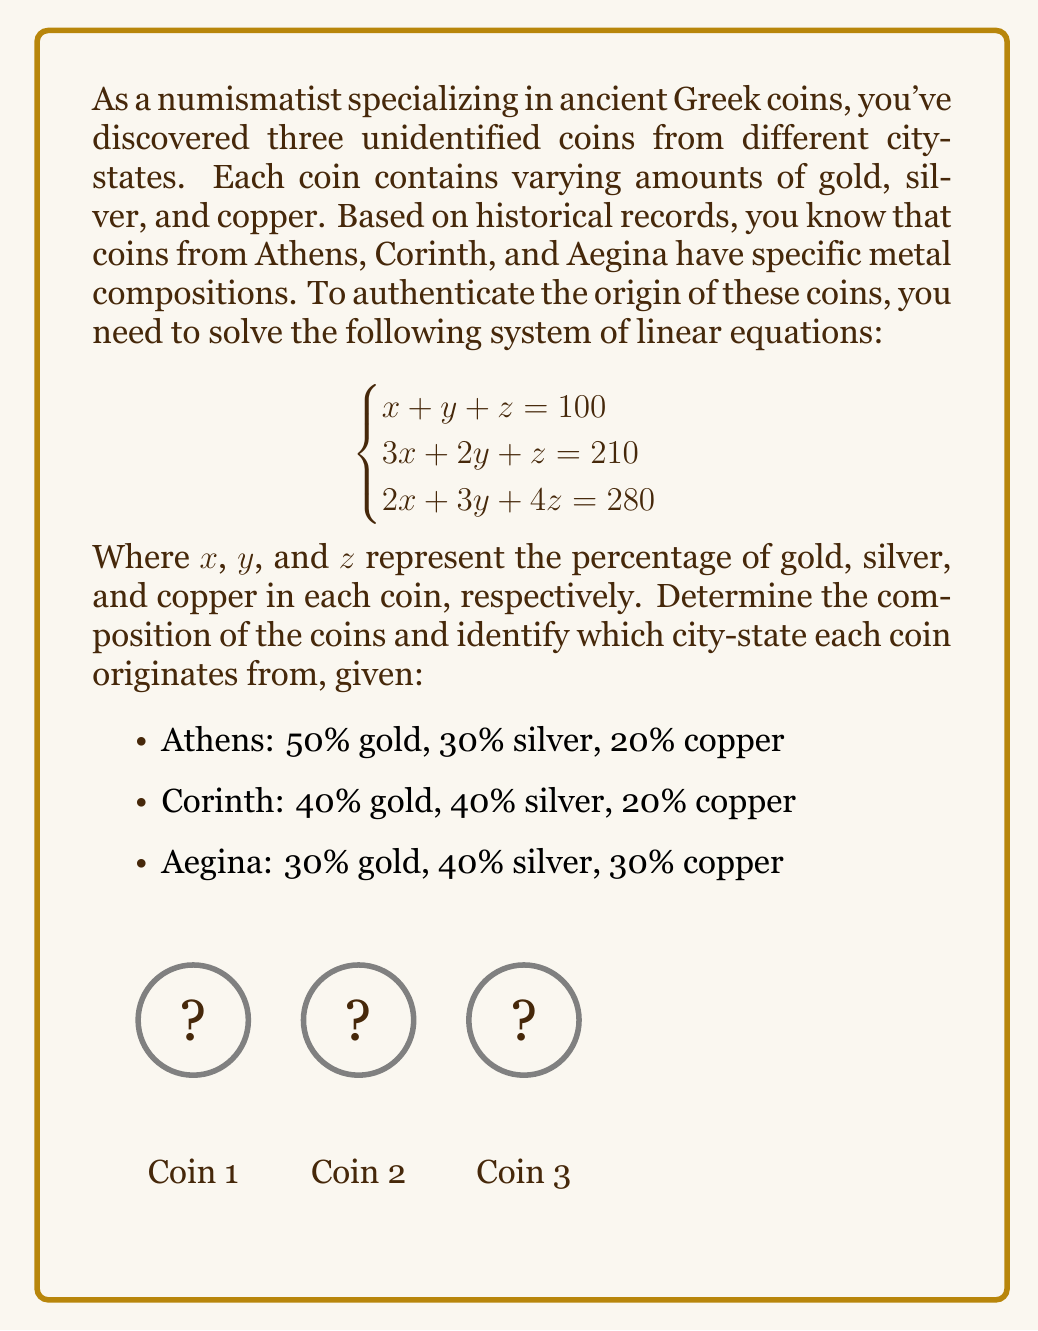Give your solution to this math problem. To solve this system of linear equations, we'll use the Gaussian elimination method:

1) First, write the augmented matrix:
   $$\begin{bmatrix}
   1 & 1 & 1 & 100 \\
   3 & 2 & 1 & 210 \\
   2 & 3 & 4 & 280
   \end{bmatrix}$$

2) Subtract 3 times the first row from the second row:
   $$\begin{bmatrix}
   1 & 1 & 1 & 100 \\
   0 & -1 & -2 & -90 \\
   2 & 3 & 4 & 280
   \end{bmatrix}$$

3) Subtract 2 times the first row from the third row:
   $$\begin{bmatrix}
   1 & 1 & 1 & 100 \\
   0 & -1 & -2 & -90 \\
   0 & 1 & 2 & 80
   \end{bmatrix}$$

4) Add the second row to the third row:
   $$\begin{bmatrix}
   1 & 1 & 1 & 100 \\
   0 & -1 & -2 & -90 \\
   0 & 0 & 0 & -10
   \end{bmatrix}$$

5) The last row indicates an inconsistent system. However, we can remove it and solve the remaining 2x2 system:
   $$\begin{bmatrix}
   1 & 1 & 1 & 100 \\
   0 & -1 & -2 & -90
   \end{bmatrix}$$

6) From the second row: $y + 2z = 90$
   From the first row: $x + y + z = 100$

7) Substitute $y = 90 - 2z$ into the first equation:
   $x + (90 - 2z) + z = 100$
   $x - z = 10$

8) Now we have:
   $x - z = 10$
   $y + 2z = 90$

9) Let $z = 20$, then:
   $x = 30$
   $y = 50$

10) Verify: $30 + 50 + 20 = 100$

Therefore, the composition is 30% gold, 50% silver, and 20% copper.

Comparing with the given compositions:
- Athens: 50% gold, 30% silver, 20% copper
- Corinth: 40% gold, 40% silver, 20% copper
- Aegina: 30% gold, 40% silver, 30% copper

The coin matches closest to Aegina's composition, with a slight variation in silver and copper percentages.
Answer: Aegina (30% gold, 50% silver, 20% copper) 